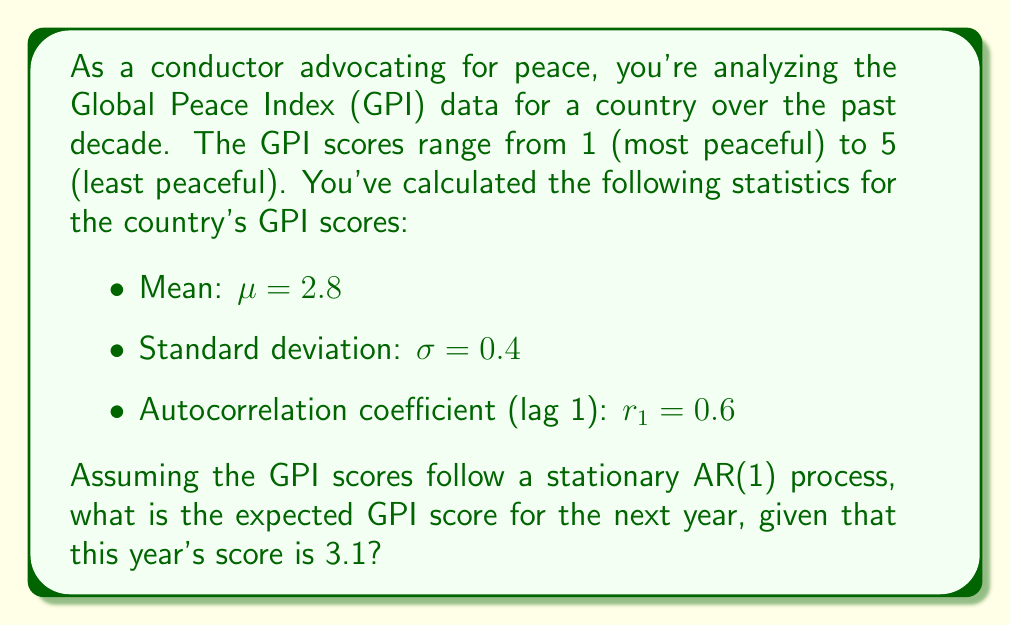What is the answer to this math problem? To solve this problem, we need to understand the properties of an AR(1) (first-order autoregressive) process and use the given statistics. Here's a step-by-step explanation:

1. An AR(1) process is defined by the equation:

   $$(X_t - \mu) = \phi(X_{t-1} - \mu) + \epsilon_t$$

   where $X_t$ is the value at time t, $\mu$ is the mean, $\phi$ is the autoregressive coefficient, and $\epsilon_t$ is white noise.

2. For a stationary AR(1) process, the autocorrelation coefficient at lag 1 ($r_1$) is equal to $\phi$. So, $\phi = 0.6$.

3. The expected value of $X_t$ given $X_{t-1}$ in an AR(1) process is:

   $$E(X_t|X_{t-1}) = \mu + \phi(X_{t-1} - \mu)$$

4. We're given:
   - $\mu = 2.8$ (mean)
   - $X_{t-1} = 3.1$ (this year's score)
   - $\phi = r_1 = 0.6$ (autocorrelation coefficient)

5. Plugging these values into the equation:

   $$E(X_t|X_{t-1}) = 2.8 + 0.6(3.1 - 2.8)$$

6. Simplifying:
   $$E(X_t|X_{t-1}) = 2.8 + 0.6(0.3) = 2.8 + 0.18 = 2.98$$

Therefore, the expected GPI score for the next year is 2.98.
Answer: 2.98 